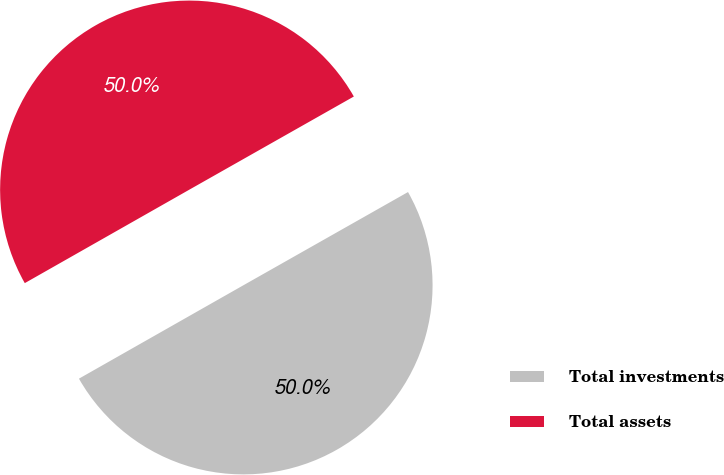<chart> <loc_0><loc_0><loc_500><loc_500><pie_chart><fcel>Total investments<fcel>Total assets<nl><fcel>49.98%<fcel>50.02%<nl></chart> 